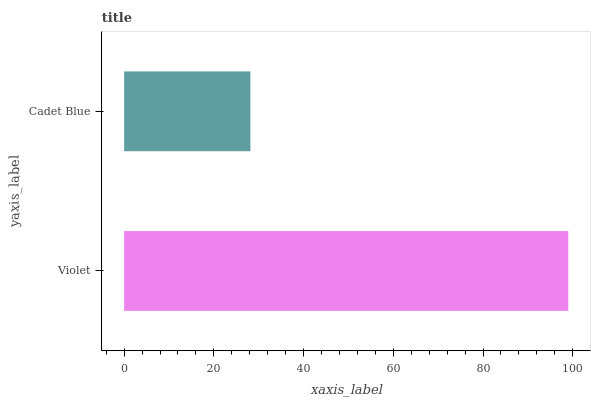Is Cadet Blue the minimum?
Answer yes or no. Yes. Is Violet the maximum?
Answer yes or no. Yes. Is Cadet Blue the maximum?
Answer yes or no. No. Is Violet greater than Cadet Blue?
Answer yes or no. Yes. Is Cadet Blue less than Violet?
Answer yes or no. Yes. Is Cadet Blue greater than Violet?
Answer yes or no. No. Is Violet less than Cadet Blue?
Answer yes or no. No. Is Violet the high median?
Answer yes or no. Yes. Is Cadet Blue the low median?
Answer yes or no. Yes. Is Cadet Blue the high median?
Answer yes or no. No. Is Violet the low median?
Answer yes or no. No. 